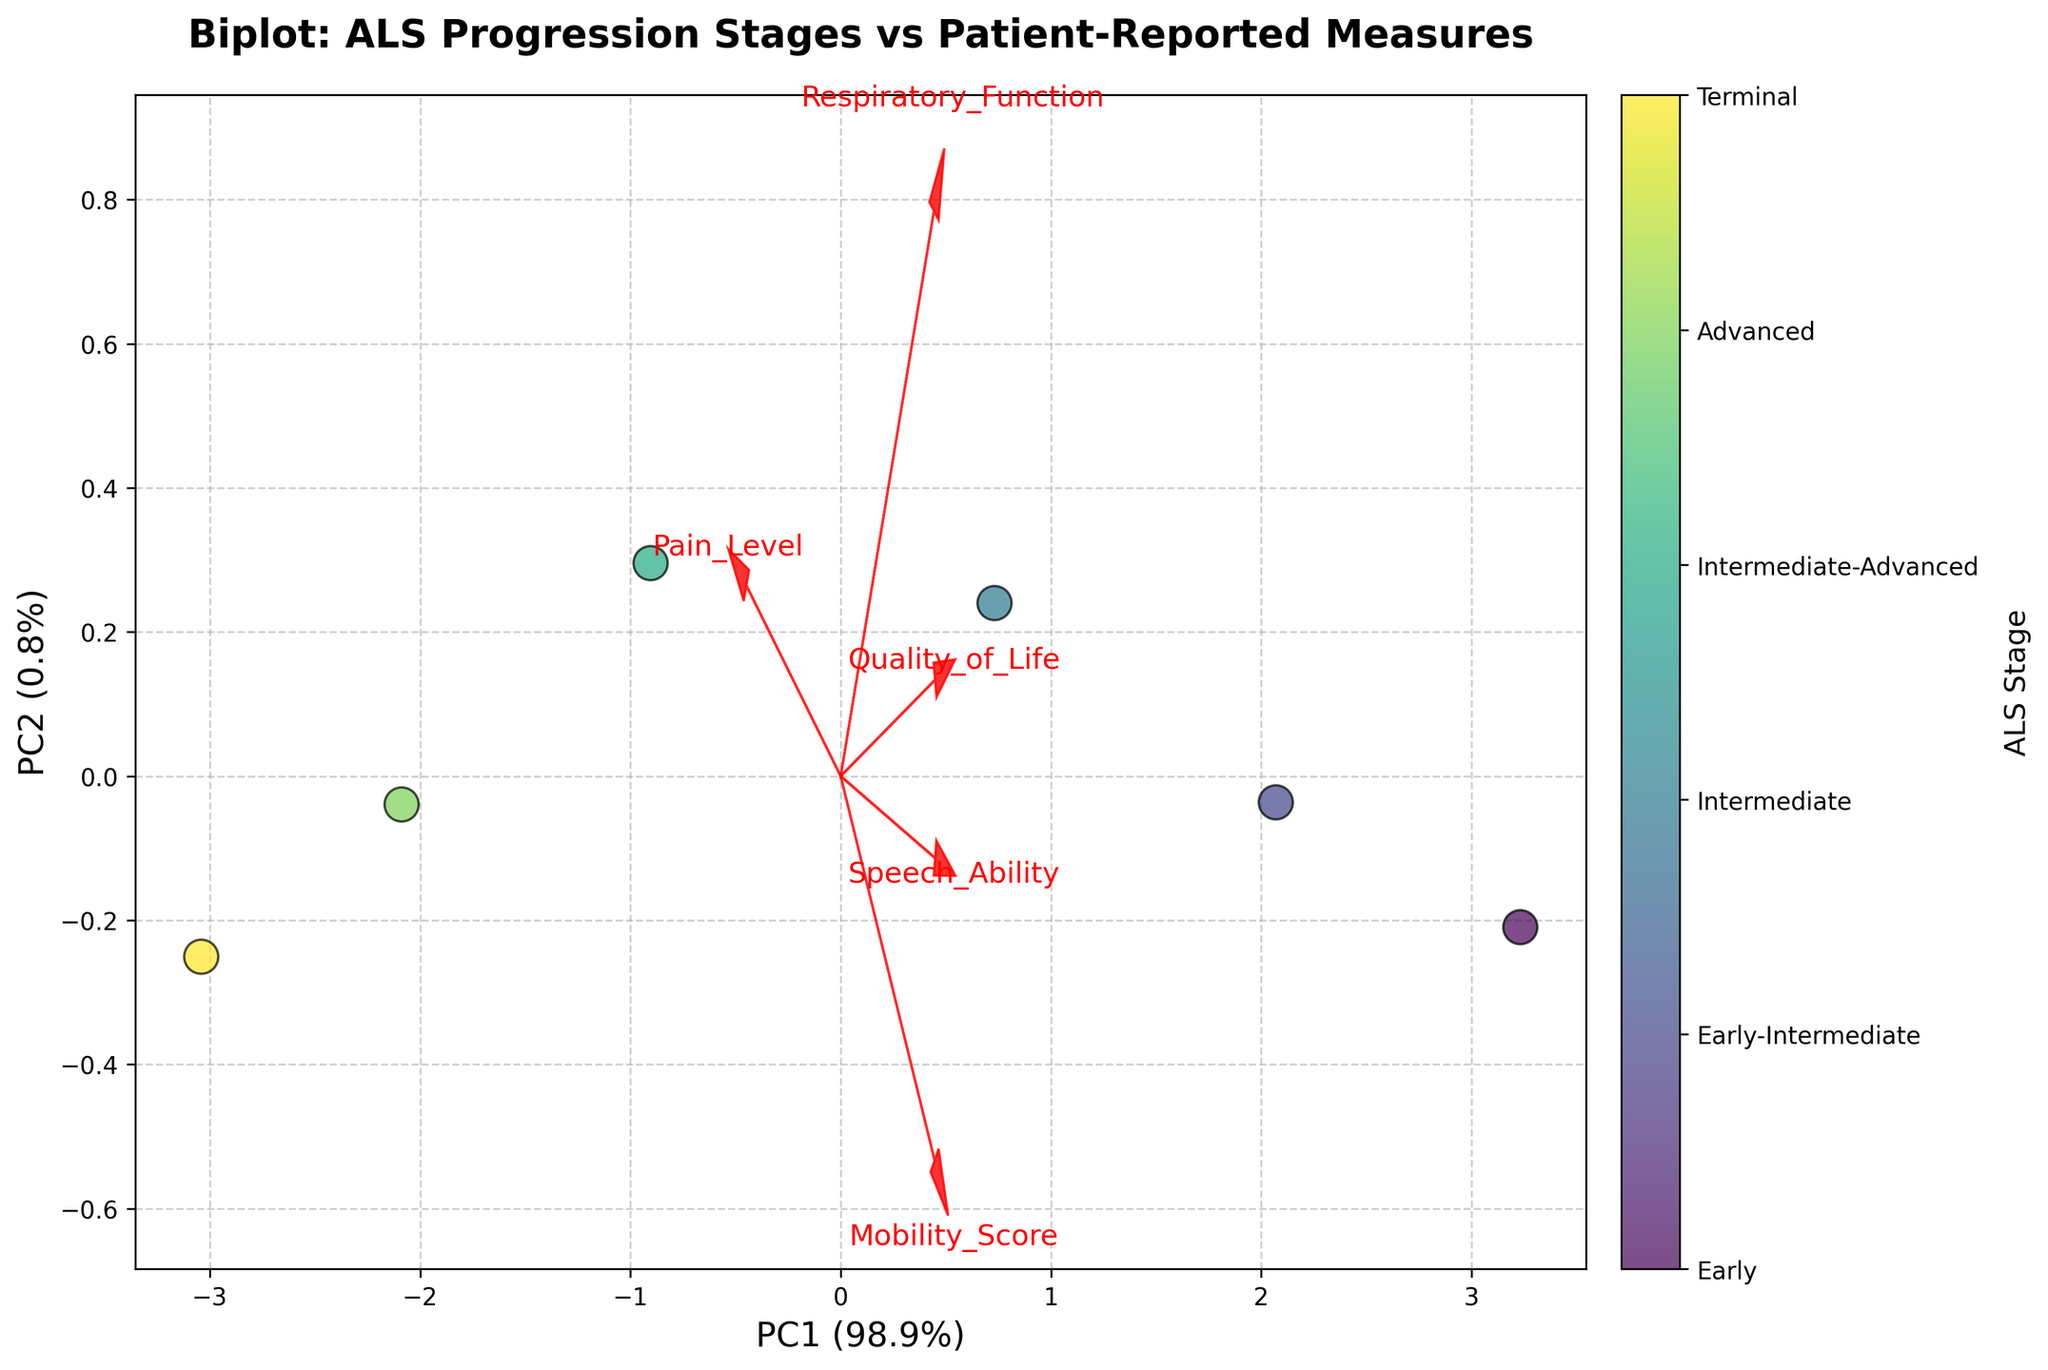What does the title of the plot indicate? The title "Biplot: ALS Progression Stages vs Patient-Reported Measures" indicates the plot visualizes the relationship between ALS progression stages and measures reported by patients, such as pain level, mobility, speech ability, respiratory function, and quality of life.
Answer: It shows the relationship between ALS progression stages and patient-reported measures Which PC (principal component) accounts for the most variance? The x-axis labeled "PC1 (percentage%)" shows the first principal component. The percentage value indicates how much variance it accounts for. Here, PC1 accounts for a larger percentage than PC2.
Answer: PC1 How are the ALS stages represented on the biplot? The different ALS stages are represented by colored scatter points on the biplot. Each stage is indicated by a different color.
Answer: Colored scatter points What do the red arrows on the biplot represent? The red arrows represent the direction and magnitude of the original features (Pain Level, Mobility Score, Speech Ability, Respiratory Function, Quality of Life) in the transformed PCA space, showing their correlations with the principal components.
Answer: Original features correlations Which original feature has the largest positive correlation with PC1? By observing the arrows, we can see which feature points most directly along the PC1 axis. The feature with the arrow having the longest projection on PC1 has the largest positive correlation with it.
Answer: Pain Level Are ALS stages more separated along PC1 or PC2? By observing the scatter plot points, we can see if they spread out more along the x-axis (PC1) or y-axis (PC2). The stages seem more differentiated along PC1 because the spread is wider along the x-axis.
Answer: PC1 Which original feature is negatively correlated with PC1? Features with arrows pointing in the negative direction along the PC1 axis have a negative correlation. For example, Mobility Score has a negatively directed arrow along PC1.
Answer: Mobility Score Which ALS stage is associated with the highest pain level according to the plot? By referring to the color bar and scatter points, we can locate the point labeled "Terminal" which is associated with the highest Pain Level.
Answer: Terminal Is the Quality of Life feature more aligned with PC1 or PC2? We check the direction of the Quality of Life arrow and see its alignment. It points more towards PC1, indicating it's more aligned with PC1.
Answer: PC1 What does the spread of data points between early and advanced stages suggest about variance? By observing the scatter points, early stages have less spread, indicating lower variance, while advanced stages show more spread along PC1, indicating higher variance in these measures.
Answer: Increased variance in advanced stages 